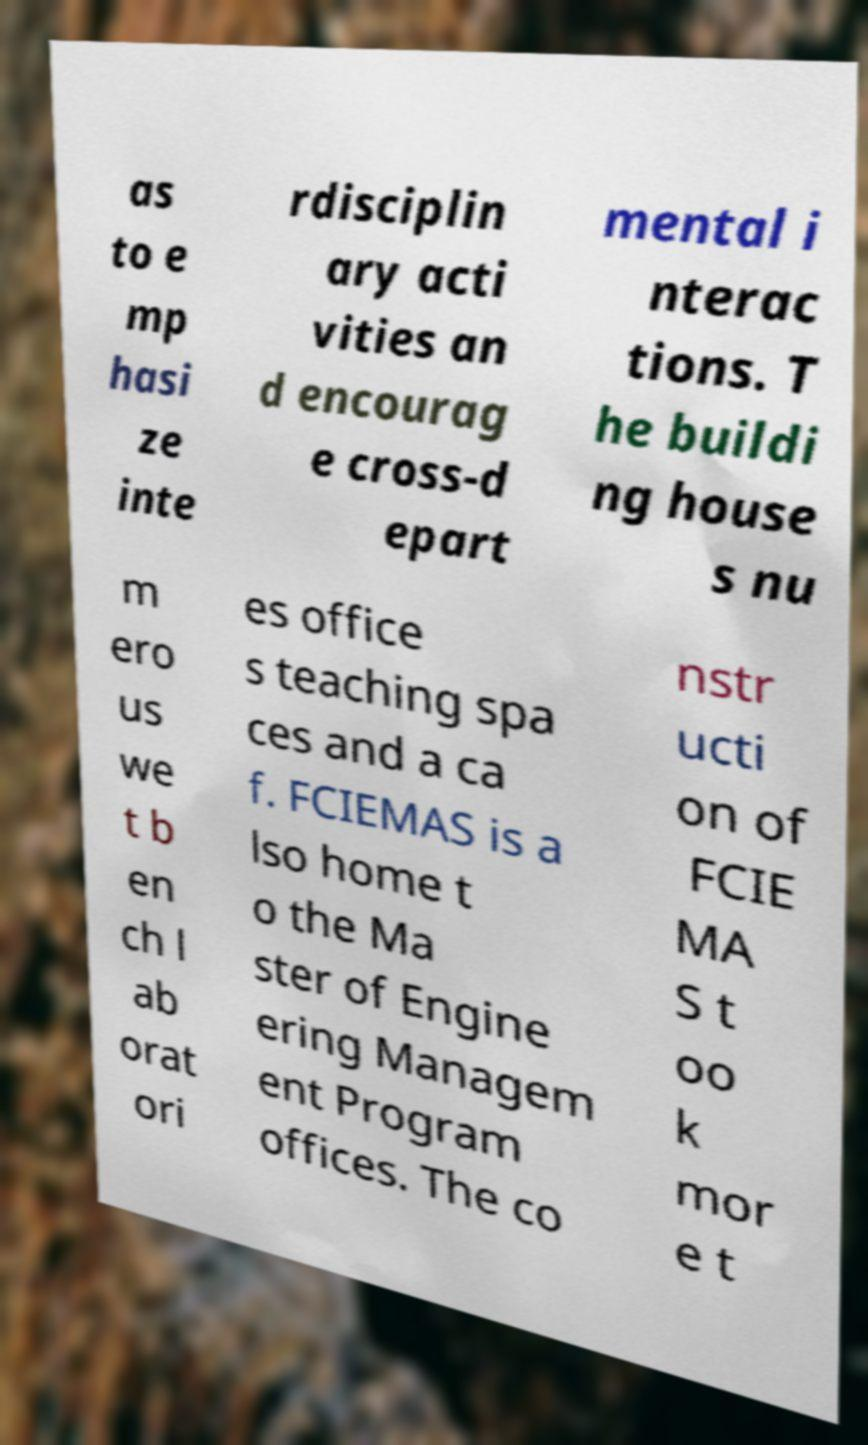For documentation purposes, I need the text within this image transcribed. Could you provide that? as to e mp hasi ze inte rdisciplin ary acti vities an d encourag e cross-d epart mental i nterac tions. T he buildi ng house s nu m ero us we t b en ch l ab orat ori es office s teaching spa ces and a ca f. FCIEMAS is a lso home t o the Ma ster of Engine ering Managem ent Program offices. The co nstr ucti on of FCIE MA S t oo k mor e t 